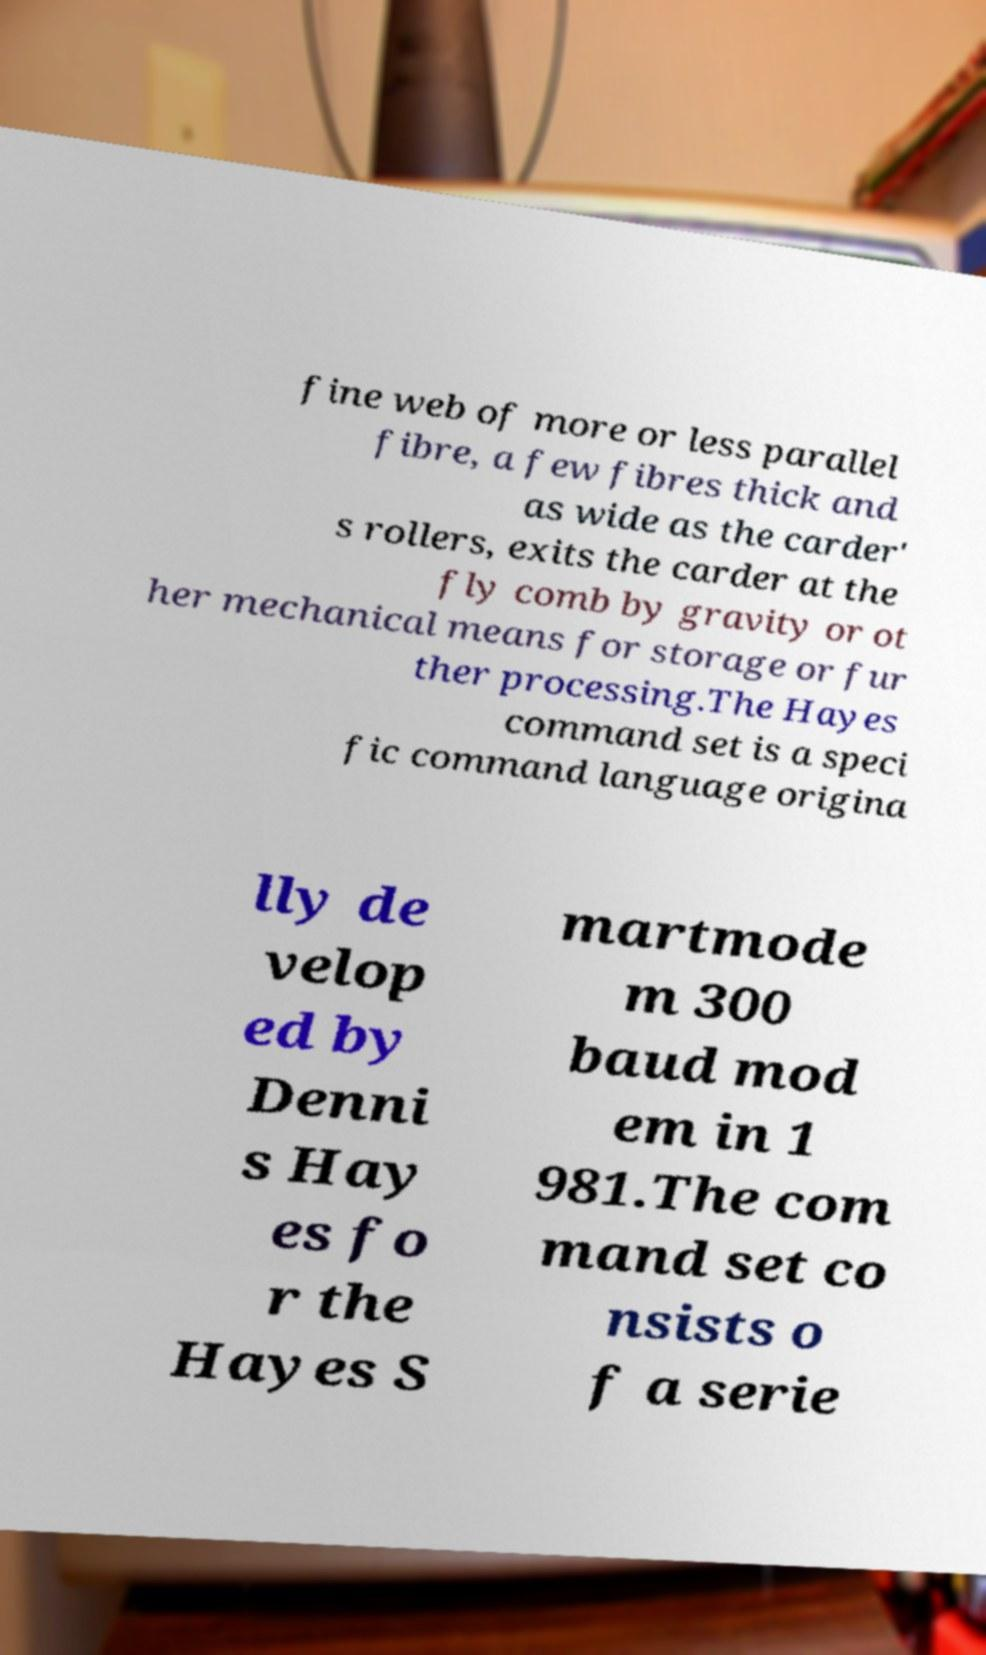What messages or text are displayed in this image? I need them in a readable, typed format. fine web of more or less parallel fibre, a few fibres thick and as wide as the carder' s rollers, exits the carder at the fly comb by gravity or ot her mechanical means for storage or fur ther processing.The Hayes command set is a speci fic command language origina lly de velop ed by Denni s Hay es fo r the Hayes S martmode m 300 baud mod em in 1 981.The com mand set co nsists o f a serie 